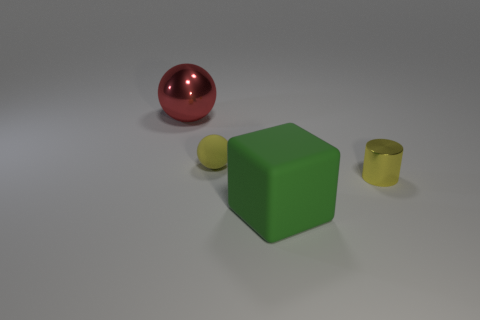Add 2 brown matte blocks. How many objects exist? 6 Subtract all metallic cylinders. Subtract all small metallic cylinders. How many objects are left? 2 Add 1 big green cubes. How many big green cubes are left? 2 Add 1 big blue cylinders. How many big blue cylinders exist? 1 Subtract 0 gray cylinders. How many objects are left? 4 